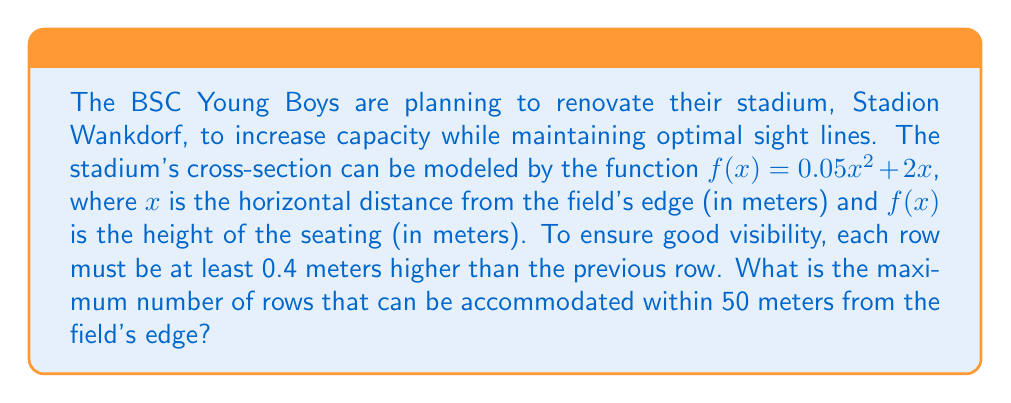Give your solution to this math problem. Let's approach this problem step-by-step:

1) The height difference between any two points on the curve is given by:

   $$\Delta y = f(x_2) - f(x_1) = 0.05(x_2^2 - x_1^2) + 2(x_2 - x_1)$$

2) We need to find the minimum distance $\Delta x$ between rows such that $\Delta y \geq 0.4$ meters.

3) Let $x_2 = x_1 + \Delta x$. Substituting into the equation from step 1:

   $$0.4 \leq 0.05((x_1 + \Delta x)^2 - x_1^2) + 2\Delta x$$

4) Expanding the squared term:

   $$0.4 \leq 0.05(x_1^2 + 2x_1\Delta x + (\Delta x)^2 - x_1^2) + 2\Delta x$$

5) Simplifying:

   $$0.4 \leq 0.1x_1\Delta x + 0.05(\Delta x)^2 + 2\Delta x$$

6) This inequality needs to hold for all $x_1$ from 0 to 50. The most restrictive case is when $x_1 = 0$:

   $$0.4 \leq 0.05(\Delta x)^2 + 2\Delta x$$

7) Solving this quadratic inequality:

   $$0.05(\Delta x)^2 + 2\Delta x - 0.4 \geq 0$$

   $$\Delta x \geq \frac{-2 + \sqrt{4 + 4(0.05)(0.4)}}{0.1} \approx 0.198$$

8) Therefore, the minimum distance between rows is approximately 0.198 meters.

9) The maximum number of rows is thus:

   $$\text{Number of rows} = \left\lfloor\frac{50}{0.198}\right\rfloor = 252$$

Where $\lfloor \cdot \rfloor$ denotes the floor function.
Answer: The maximum number of rows that can be accommodated within 50 meters from the field's edge is 252. 